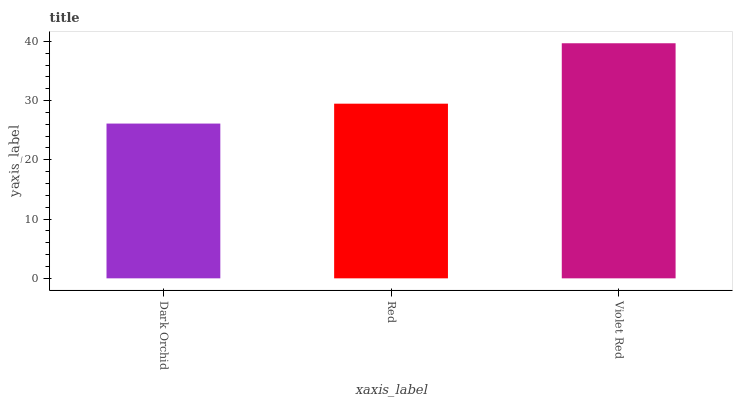Is Dark Orchid the minimum?
Answer yes or no. Yes. Is Violet Red the maximum?
Answer yes or no. Yes. Is Red the minimum?
Answer yes or no. No. Is Red the maximum?
Answer yes or no. No. Is Red greater than Dark Orchid?
Answer yes or no. Yes. Is Dark Orchid less than Red?
Answer yes or no. Yes. Is Dark Orchid greater than Red?
Answer yes or no. No. Is Red less than Dark Orchid?
Answer yes or no. No. Is Red the high median?
Answer yes or no. Yes. Is Red the low median?
Answer yes or no. Yes. Is Violet Red the high median?
Answer yes or no. No. Is Violet Red the low median?
Answer yes or no. No. 